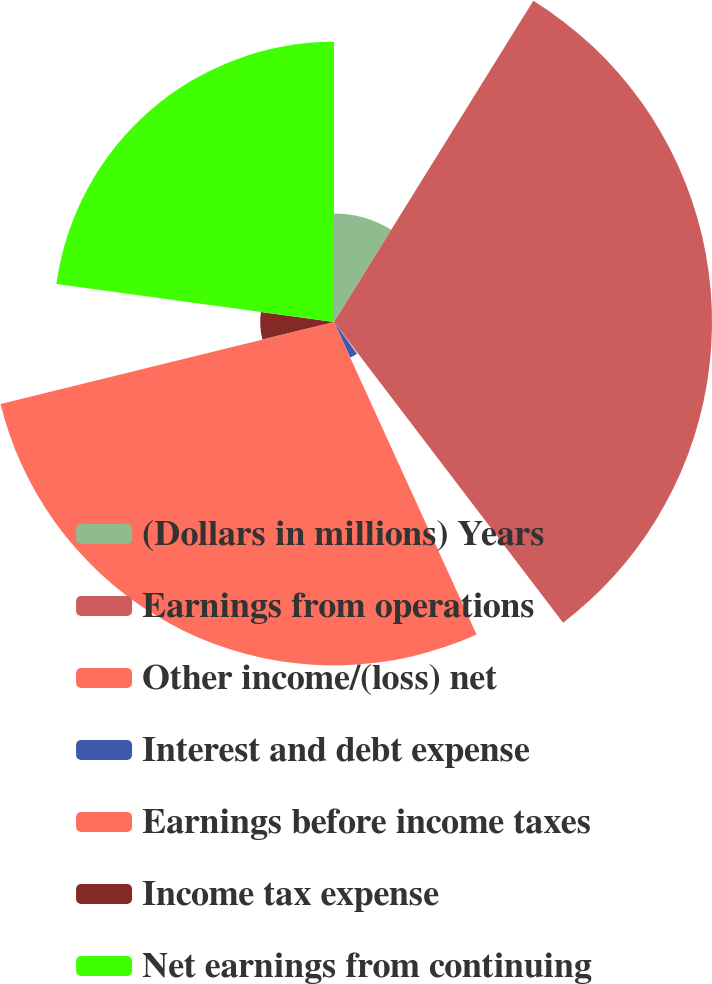<chart> <loc_0><loc_0><loc_500><loc_500><pie_chart><fcel>(Dollars in millions) Years<fcel>Earnings from operations<fcel>Other income/(loss) net<fcel>Interest and debt expense<fcel>Earnings before income taxes<fcel>Income tax expense<fcel>Net earnings from continuing<nl><fcel>8.84%<fcel>30.8%<fcel>0.36%<fcel>3.19%<fcel>27.98%<fcel>6.01%<fcel>22.83%<nl></chart> 